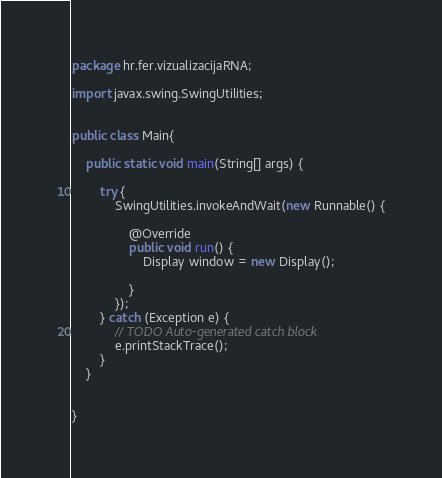<code> <loc_0><loc_0><loc_500><loc_500><_Java_>package hr.fer.vizualizacijaRNA;

import javax.swing.SwingUtilities;


public class Main{
	
	public static void main(String[] args) {
		
		try {
			SwingUtilities.invokeAndWait(new Runnable() {
				
				@Override
				public void run() {
					Display window = new Display();
					
				}
			});
		} catch (Exception e) {
			// TODO Auto-generated catch block
			e.printStackTrace();
		}
	}

	
}
</code> 